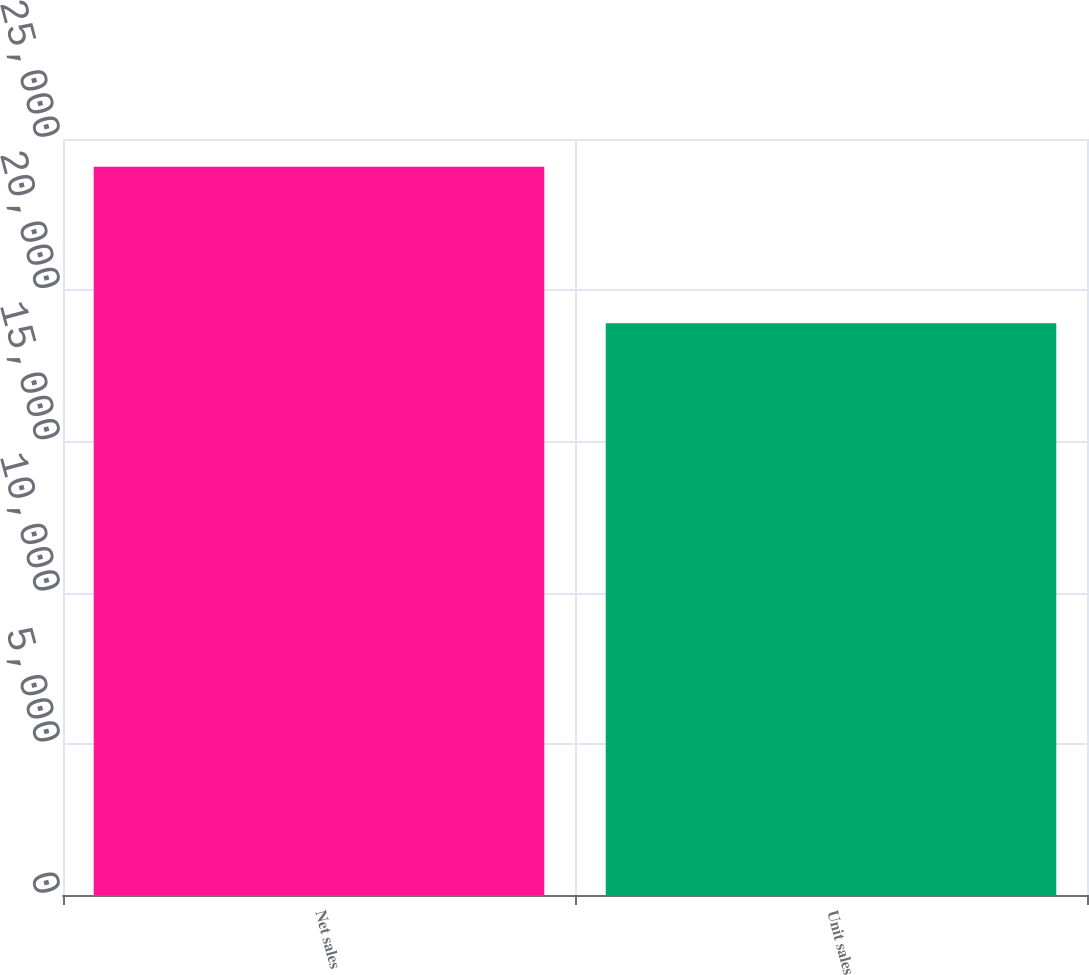<chart> <loc_0><loc_0><loc_500><loc_500><bar_chart><fcel>Net sales<fcel>Unit sales<nl><fcel>24079<fcel>18906<nl></chart> 